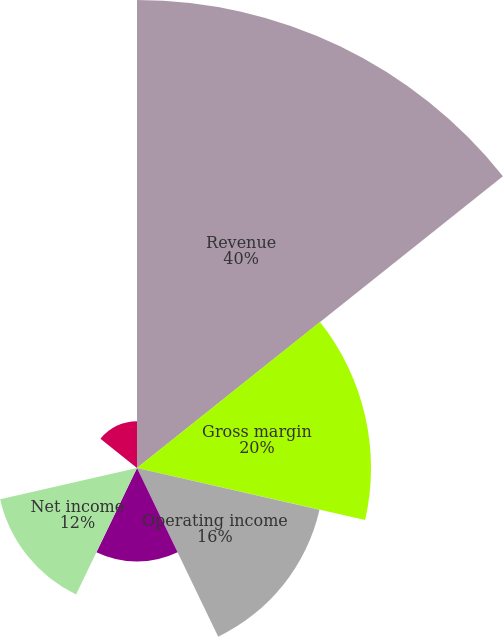<chart> <loc_0><loc_0><loc_500><loc_500><pie_chart><fcel>Revenue<fcel>Gross margin<fcel>Operating income<fcel>Income from continuing<fcel>Net income<fcel>Basic earnings per share from<fcel>Diluted earnings per share<nl><fcel>40.0%<fcel>20.0%<fcel>16.0%<fcel>8.0%<fcel>12.0%<fcel>0.0%<fcel>4.0%<nl></chart> 